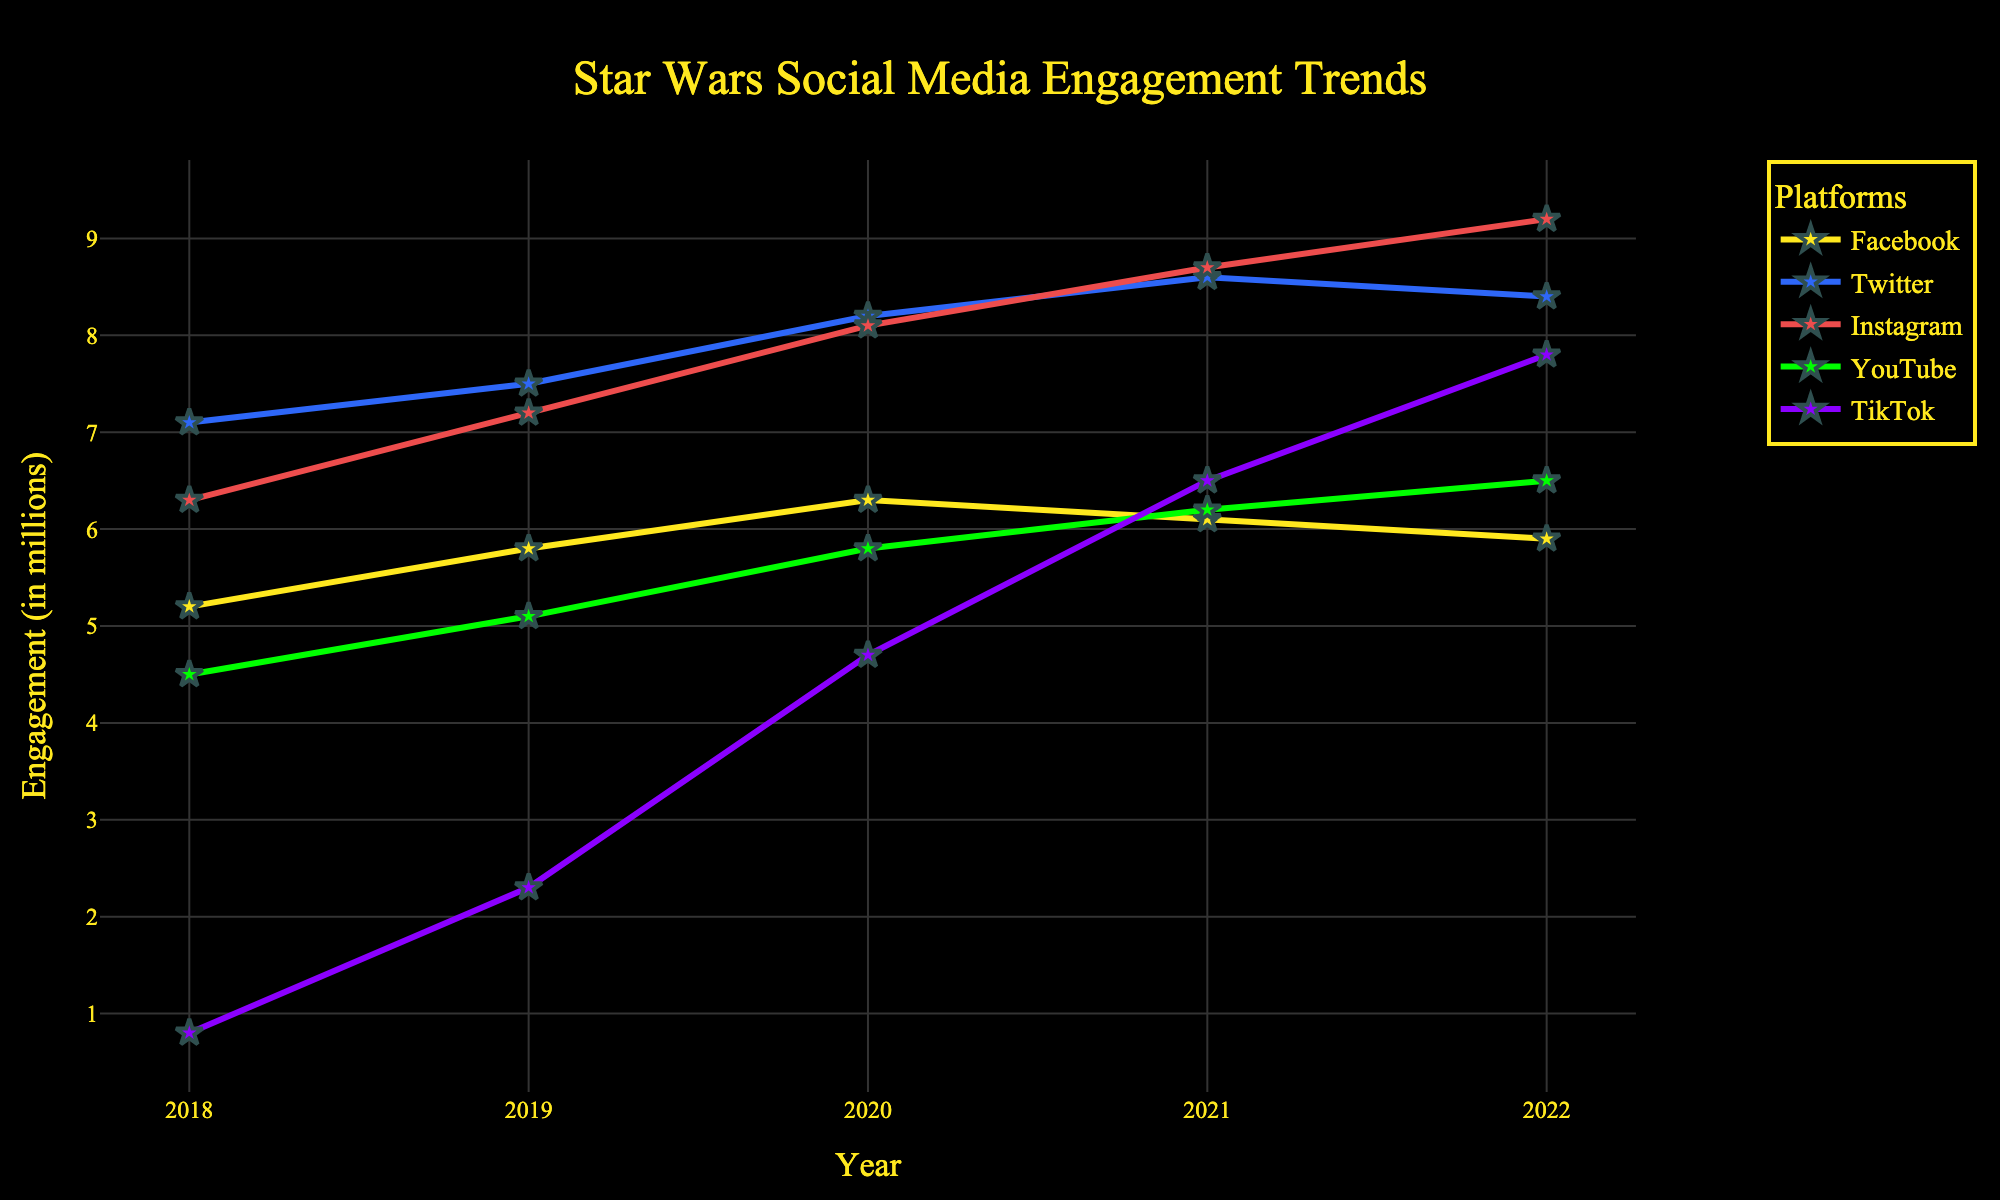Which social media platform saw the largest increase in engagement from 2018 to 2022? To determine the platform with the largest increase, calculate the difference in engagement from 2018 to 2022 for each platform. Facebook: 5.9 - 5.2 = 0.7, Twitter: 8.4 - 7.1 = 1.3, Instagram: 9.2 - 6.3 = 2.9, YouTube: 6.5 - 4.5 = 2.0, TikTok: 7.8 - 0.8 = 7.0. TikTok has the largest increase.
Answer: TikTok Which platform had the highest engagement in 2020? By looking at the engagement values for 2020, compare Facebook (6.3), Twitter (8.2), Instagram (8.1), YouTube (5.8), and TikTok (4.7). Twitter has the highest engagement in 2020.
Answer: Twitter What is the average engagement for YouTube from 2018 to 2022? Sum the engagement values for YouTube and divide by the number of years: (4.5 + 5.1 + 5.8 + 6.2 + 6.5) / 5 = 28.1 / 5 = 5.62.
Answer: 5.62 Between which two consecutive years did Facebook's engagement decline? Examine the year-over-year engagement values for Facebook: 2018-2019: 5.2 to 5.8 (increase), 2019-2020: 5.8 to 6.3 (increase), 2020-2021: 6.3 to 6.1 (decline), 2021-2022: 6.1 to 5.9 (decline). The decline occurred from 2020 to 2021 and 2021 to 2022.
Answer: 2020 to 2021 Which platform had the most stable engagement trend from 2018 to 2022? Look at the engagement values for each platform and check the variation: Facebook has minor fluctuations (5.2 to 6.3), Twitter steadily increases (7.1 to 8.4), Instagram steadily increases (6.3 to 9.2), YouTube steadily increases (4.5 to 6.5), TikTok rapidly increases (0.8 to 7.8). Facebook has the smallest changes.
Answer: Facebook In which year did Instagram overtake Twitter in engagement? Observing the trends for Instagram and Twitter, check the crossover points. Instagram's engagement surpasses Twitter's from 2021 onwards: 2020 - Instagram (8.1) < Twitter (8.2), 2021 - Instagram (8.7) > Twitter (8.6). Therefore, Instagram overtook Twitter in 2021.
Answer: 2021 How much more engagement did Instagram have compared to Facebook in 2022? Find the difference between Instagram and Facebook engagement in 2022: Instagram 9.2 - Facebook 5.9 = 3.3.
Answer: 3.3 